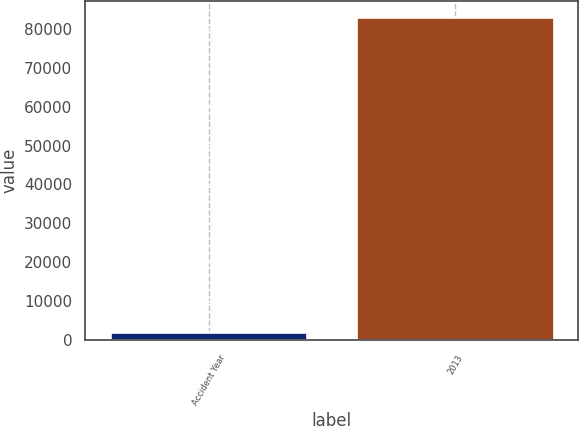Convert chart. <chart><loc_0><loc_0><loc_500><loc_500><bar_chart><fcel>Accident Year<fcel>2013<nl><fcel>2016<fcel>83119<nl></chart> 